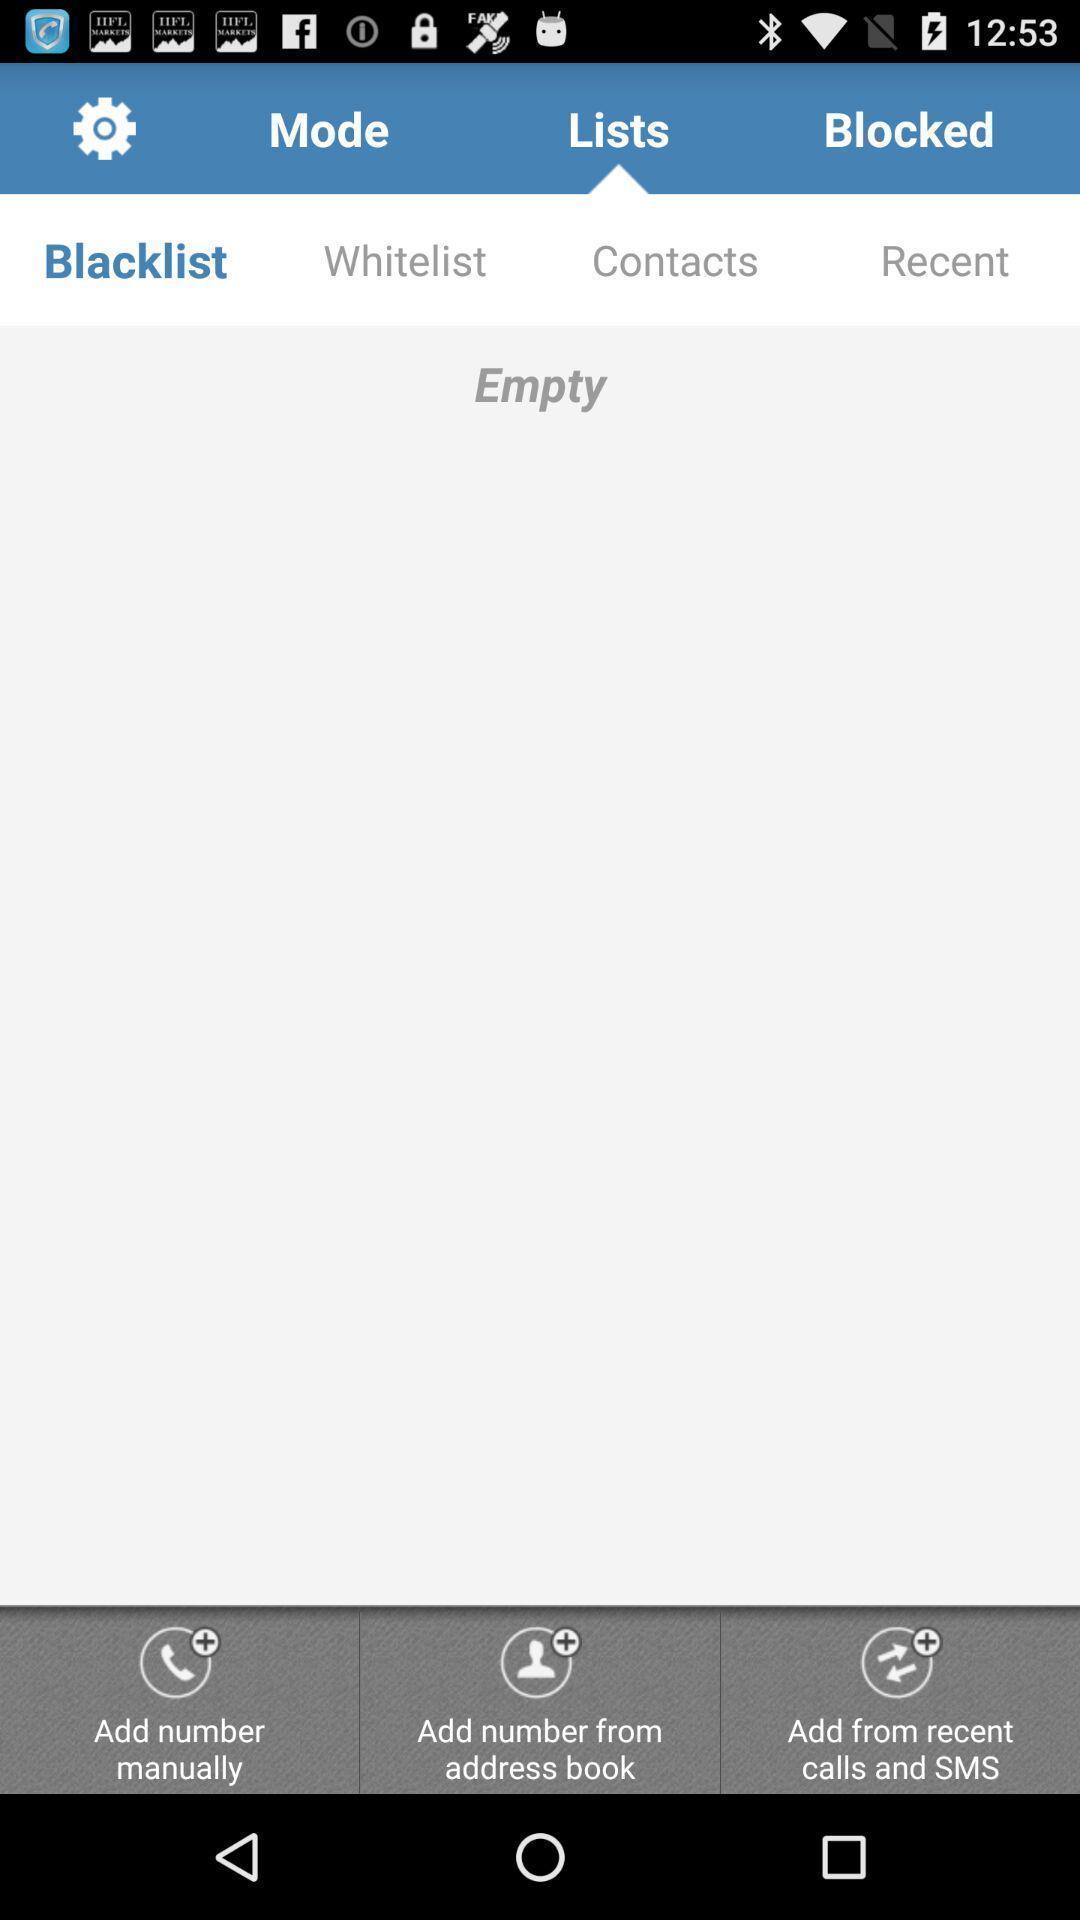Describe this image in words. Page showing blacklist on an app. 